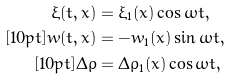Convert formula to latex. <formula><loc_0><loc_0><loc_500><loc_500>\xi ( t , x ) & = \xi _ { 1 } ( x ) \cos { \omega t } , \\ [ 1 0 p t ] w ( t , x ) & = - w _ { 1 } ( x ) \sin { \omega t } , \\ [ 1 0 p t ] \Delta \rho & = \Delta \rho _ { 1 } ( x ) \cos { \omega t } ,</formula> 